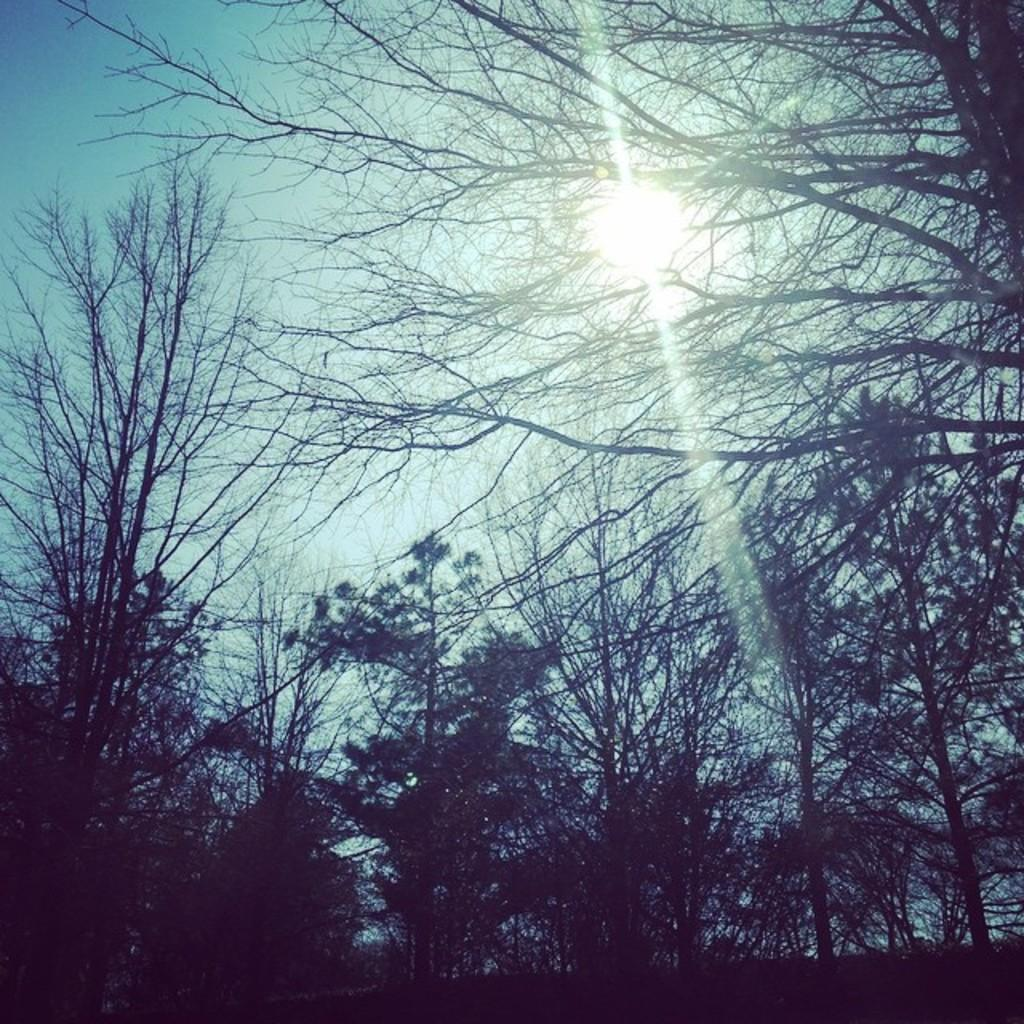What is located in the middle of the image? There are trees in the middle of the image. What can be seen behind the trees in the image? The sun is visible in the sky behind the trees. Can you tell me how many donkeys are grazing near the trees in the image? There are no donkeys present in the image; it only features trees and the sun. What is the purpose of the trees in the image? The purpose of the trees in the image cannot be determined from the image alone, as they may be decorative, provide shade, or serve other purposes. 